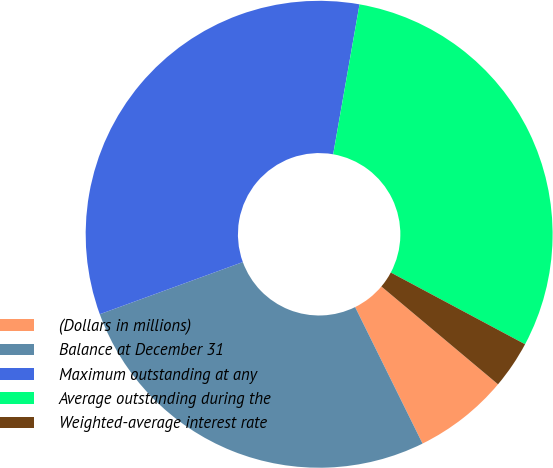Convert chart to OTSL. <chart><loc_0><loc_0><loc_500><loc_500><pie_chart><fcel>(Dollars in millions)<fcel>Balance at December 31<fcel>Maximum outstanding at any<fcel>Average outstanding during the<fcel>Weighted-average interest rate<nl><fcel>6.59%<fcel>26.74%<fcel>33.33%<fcel>30.04%<fcel>3.3%<nl></chart> 